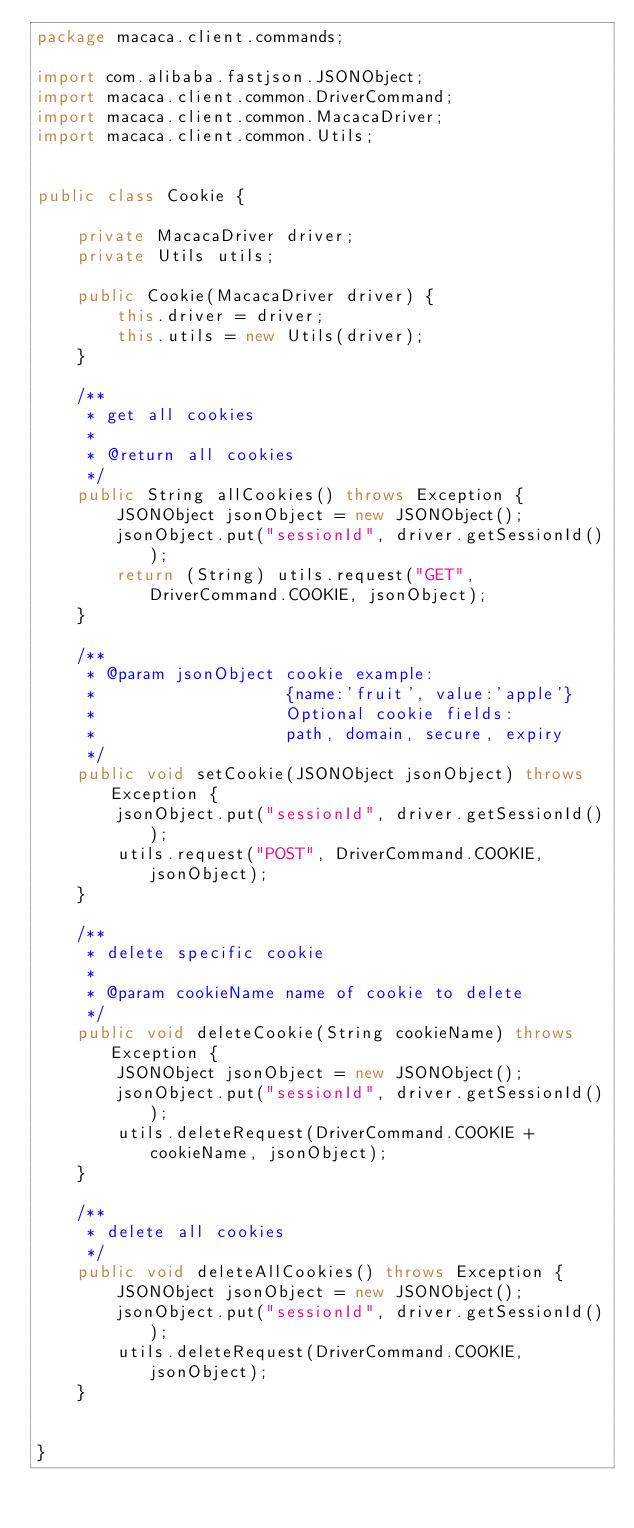<code> <loc_0><loc_0><loc_500><loc_500><_Java_>package macaca.client.commands;

import com.alibaba.fastjson.JSONObject;
import macaca.client.common.DriverCommand;
import macaca.client.common.MacacaDriver;
import macaca.client.common.Utils;


public class Cookie {

    private MacacaDriver driver;
    private Utils utils;

    public Cookie(MacacaDriver driver) {
        this.driver = driver;
        this.utils = new Utils(driver);
    }

    /**
     * get all cookies
     *
     * @return all cookies
     */
    public String allCookies() throws Exception {
        JSONObject jsonObject = new JSONObject();
        jsonObject.put("sessionId", driver.getSessionId());
        return (String) utils.request("GET", DriverCommand.COOKIE, jsonObject);
    }

    /**
     * @param jsonObject cookie example:
     *                   {name:'fruit', value:'apple'}
     *                   Optional cookie fields:
     *                   path, domain, secure, expiry
     */
    public void setCookie(JSONObject jsonObject) throws Exception {
        jsonObject.put("sessionId", driver.getSessionId());
        utils.request("POST", DriverCommand.COOKIE, jsonObject);
    }

    /**
     * delete specific cookie
     *
     * @param cookieName name of cookie to delete
     */
    public void deleteCookie(String cookieName) throws Exception {
        JSONObject jsonObject = new JSONObject();
        jsonObject.put("sessionId", driver.getSessionId());
        utils.deleteRequest(DriverCommand.COOKIE + cookieName, jsonObject);
    }

    /**
     * delete all cookies
     */
    public void deleteAllCookies() throws Exception {
        JSONObject jsonObject = new JSONObject();
        jsonObject.put("sessionId", driver.getSessionId());
        utils.deleteRequest(DriverCommand.COOKIE, jsonObject);
    }


}
</code> 